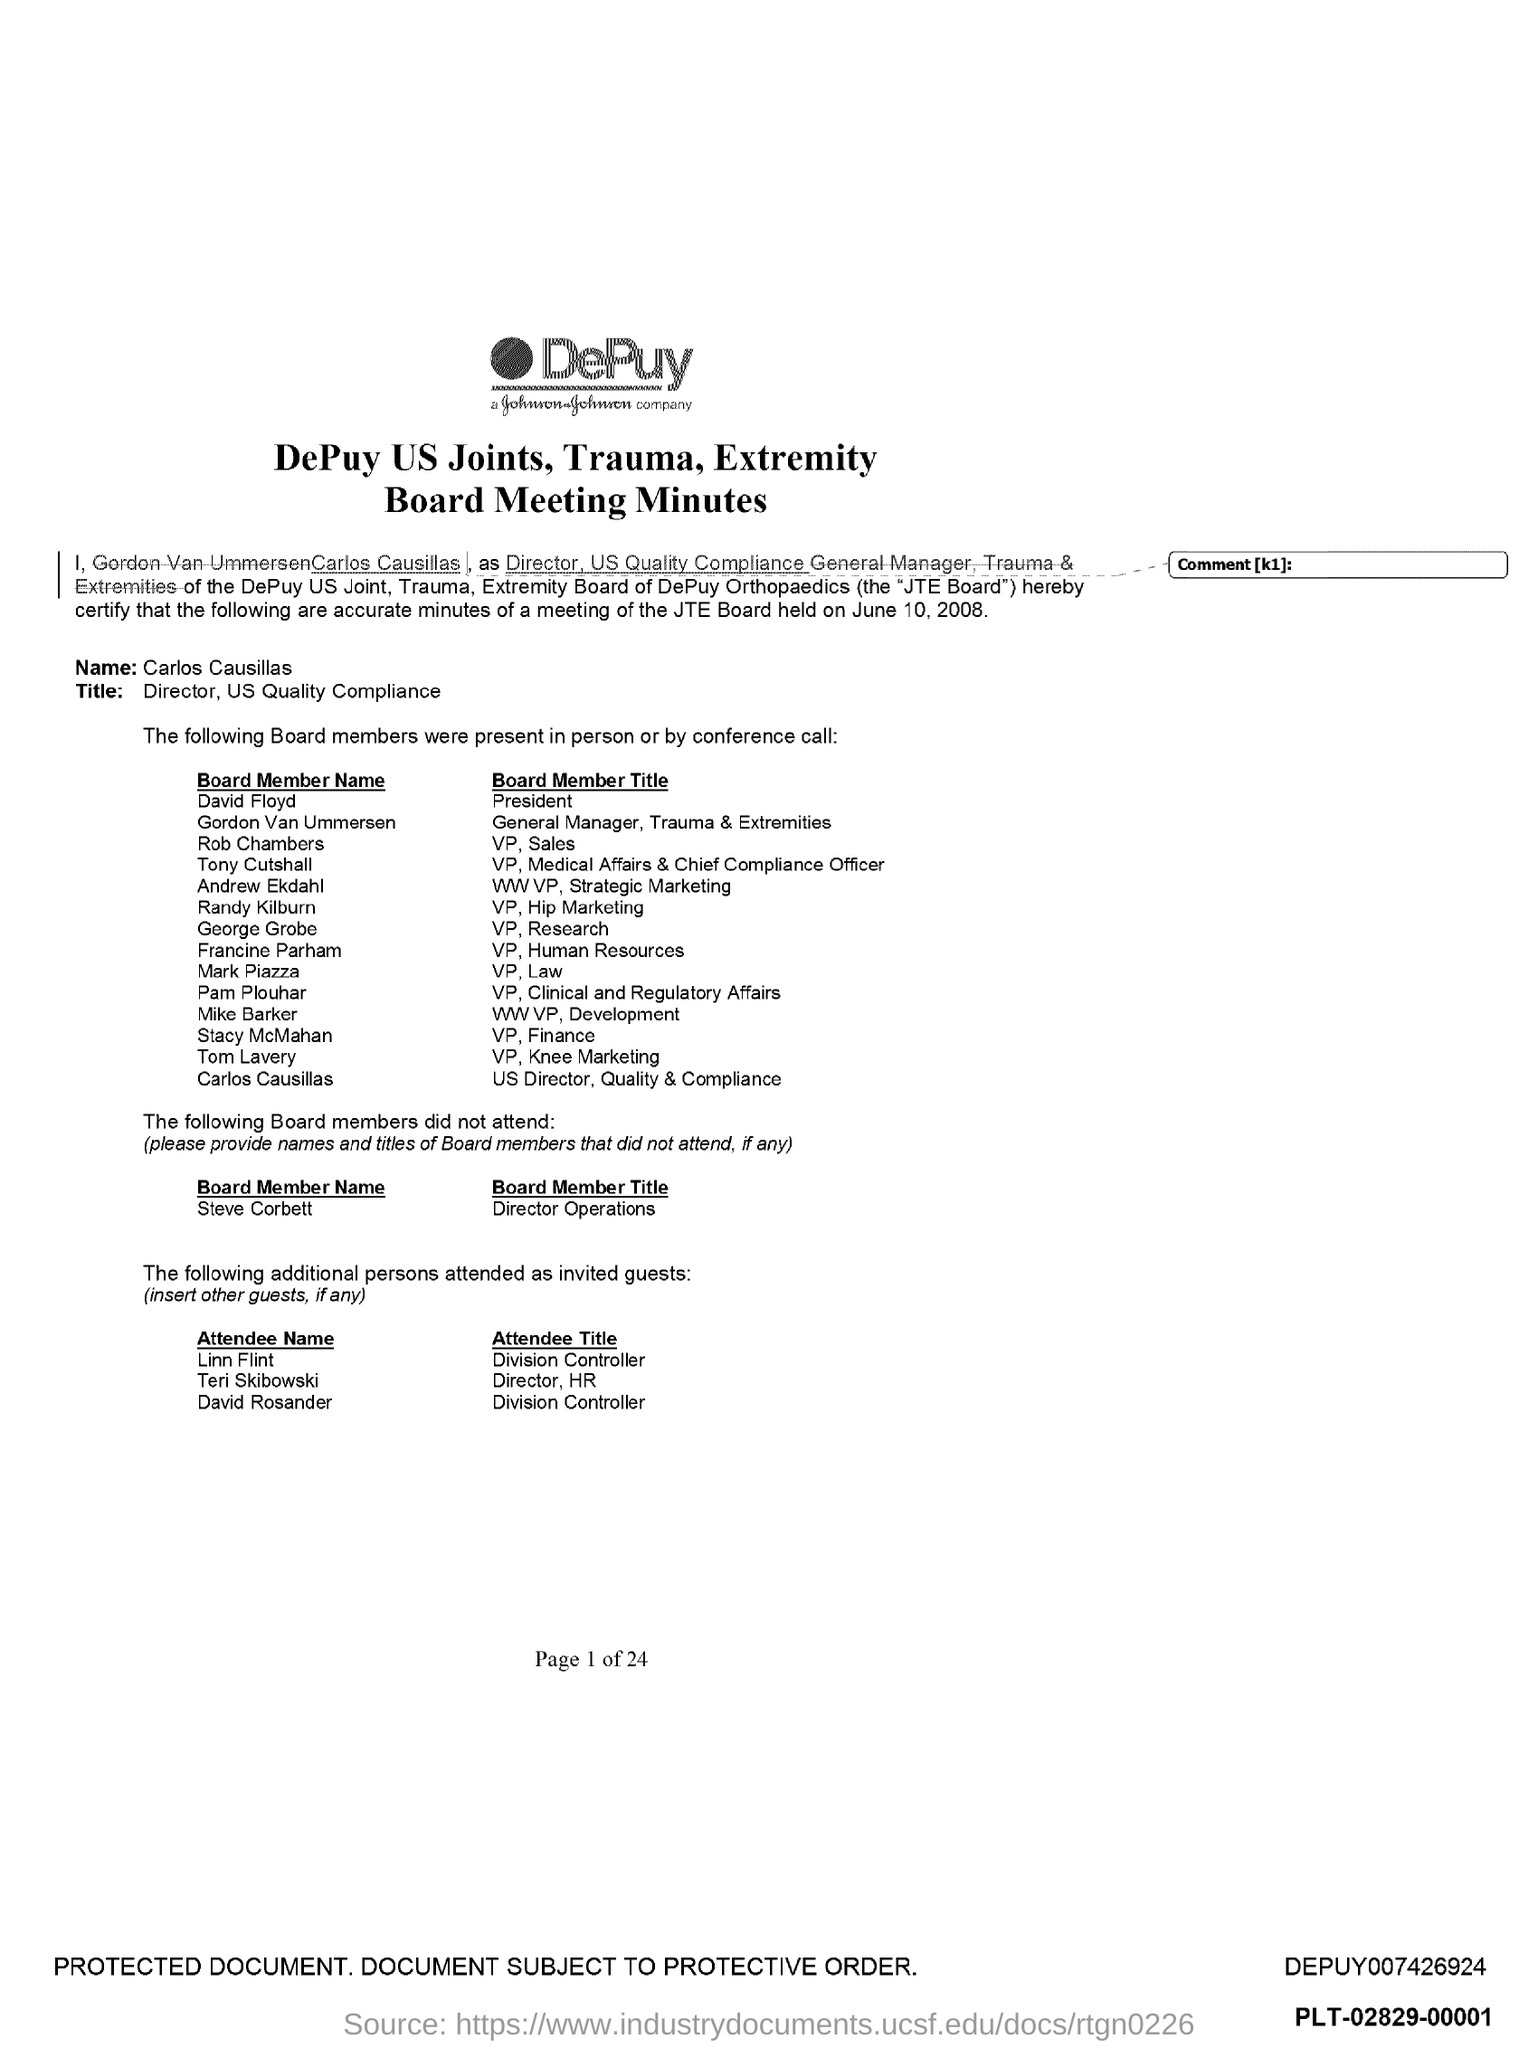What is the board member title of david floyd?
Keep it short and to the point. President. What is the title of rob chambers ?
Keep it short and to the point. VP, sales. What is the title of randy kilburn ?
Make the answer very short. VP, Hip marketing. What is the title of george grobe ?
Provide a succinct answer. VP, Research. What is the title of francine parham ?
Provide a succinct answer. VP, Human Resources. What is the position of mark piazza ?
Offer a terse response. Vp, law. What is the position of stacy mcmahan ?
Provide a succinct answer. VP, finance. What is the position of linn flint ?
Offer a very short reply. Division Controller. What is the position of david rosander ?
Provide a short and direct response. Division Controller. 